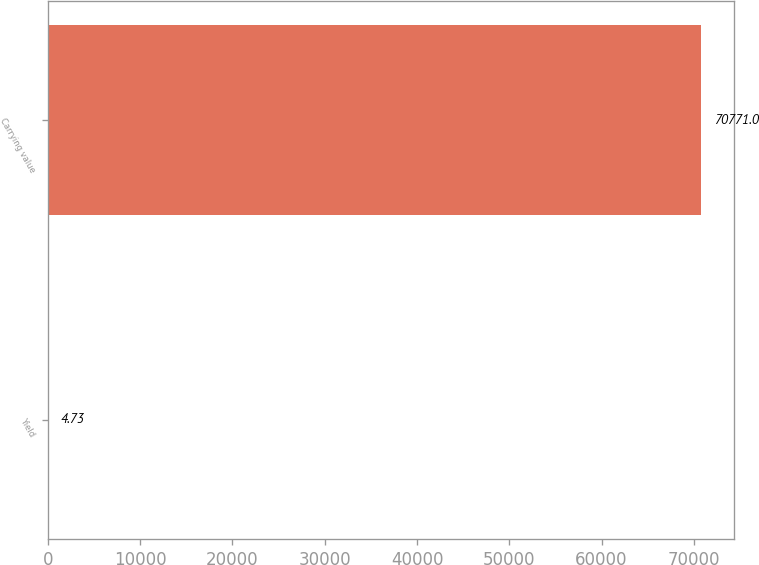Convert chart to OTSL. <chart><loc_0><loc_0><loc_500><loc_500><bar_chart><fcel>Yield<fcel>Carrying value<nl><fcel>4.73<fcel>70771<nl></chart> 